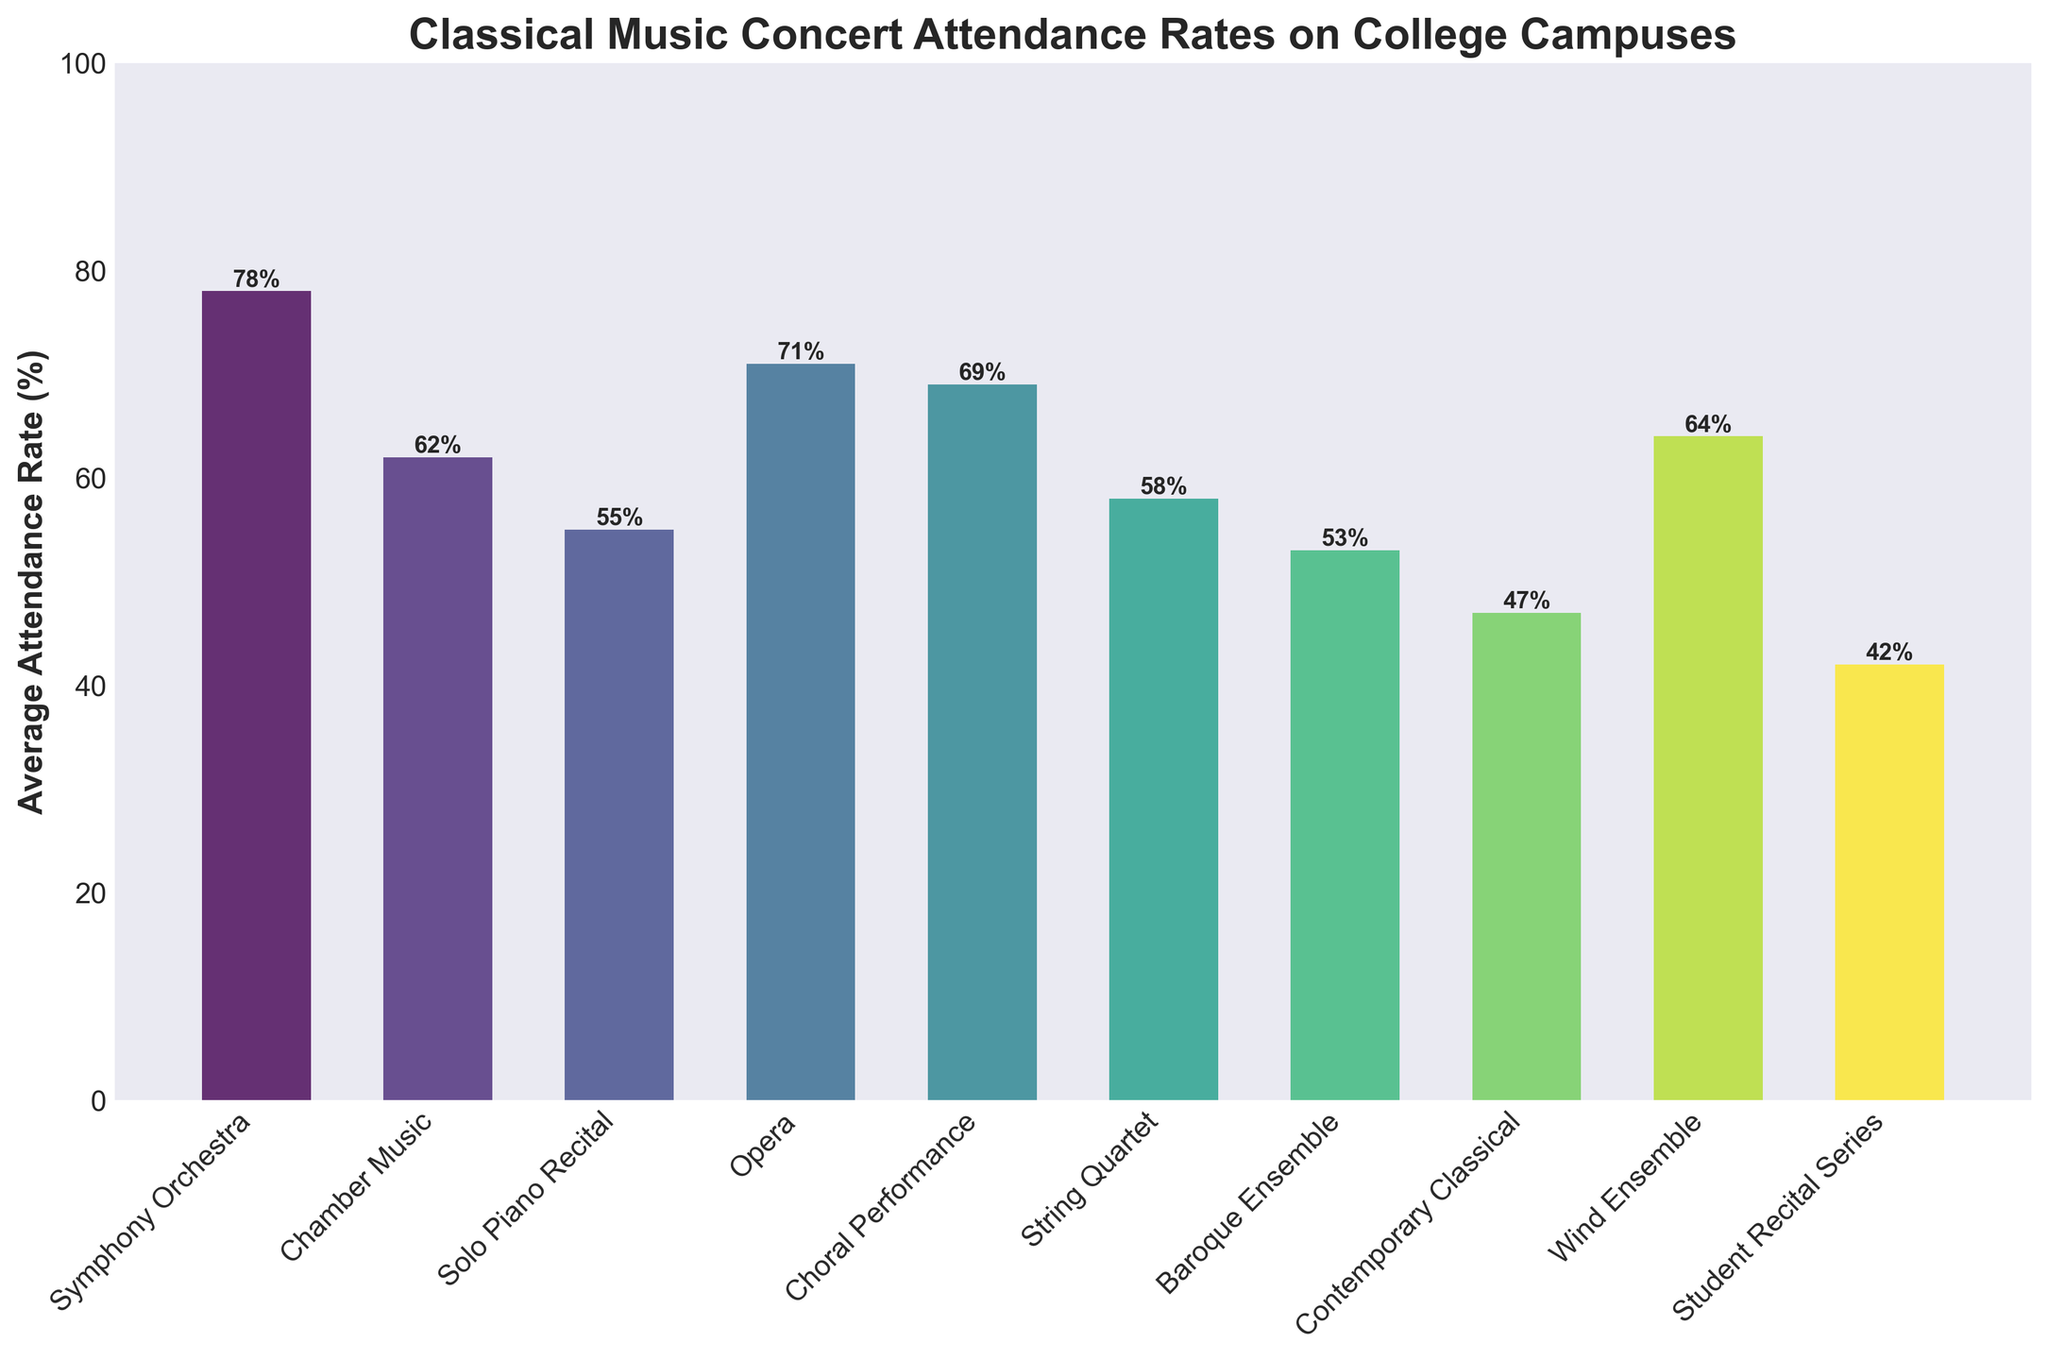What is the concert type with the highest average attendance rate? Look for the tallest bar in the bar chart. The bar representing Symphony Orchestra is the tallest, indicating an average attendance rate of 78%.
Answer: Symphony Orchestra Which concert type has a lower average attendance rate, Opera or Wind Ensemble? Compare the heights of the bars for Opera and Wind Ensemble. Opera's bar is taller than Wind Ensemble's bar, indicating higher attendance.
Answer: Wind Ensemble What is the difference in average attendance rate between Choral Performance and Chamber Music? Check the values for Choral Performance (69%) and Chamber Music (62%). Subtract the smaller value from the larger value: 69% - 62% = 7%.
Answer: 7% Which concert types have attendance rates higher than 60%? Identify the bars with heights greater than 60%. These are Symphony Orchestra, Chamber Music, Opera, Choral Performance, and Wind Ensemble.
Answer: Symphony Orchestra, Chamber Music, Opera, Choral Performance, Wind Ensemble What are the colors of the bars representing the highest and lowest attendance rates? The color of the tallest bar (Symphony Orchestra) is a lighter hue. The color of the shortest bar (Student Recital Series) is a darker hue in the colormap used.
Answer: Light (highest), Dark (lowest) What is the average attendance rate for Symphony Orchestra, Choral Performance, and String Quartet combined? Sum the attendance rates for these three concert types (78%, 69%, 58%) and divide by 3: (78 + 69 + 58) / 3 = 205 / 3 = 68.33%.
Answer: 68.33% Which concert type has an attendance rate closest to the median value of all concert types listed? List the attendance rates in ascending order and find the median value. Rates are: 42, 47, 53, 55, 58, 62, 64, 69, 71, 78. The median value is (58+62)/2=60. The closest rate is 62%.
Answer: Chamber Music Are there more concert types with attendance rates above or below 60%? Count the number of bars with heights above 60% (5 types) and below 60% (5 types). The counts are equal.
Answer: Equal What's the combined average attendance rate for baroque ensemble, contemporary classical, and student recital series? Add the attendance rates for these three concert types: 53%, 47%, and 42%. Calculate the average by summing and dividing by 3: (53 + 47 + 42) / 3 = 142 / 3 = 47.33%.
Answer: 47.33% How much more popular is a Symphony Orchestra compared to a Solo Piano Recital based on average attendance rates? The average attendance rate for Symphony Orchestra is 78%, and for Solo Piano Recital, it is 55%. Subtract the smaller value from the larger value: 78% - 55% = 23%.
Answer: 23% 